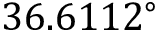<formula> <loc_0><loc_0><loc_500><loc_500>3 6 . 6 1 1 2 ^ { \circ }</formula> 